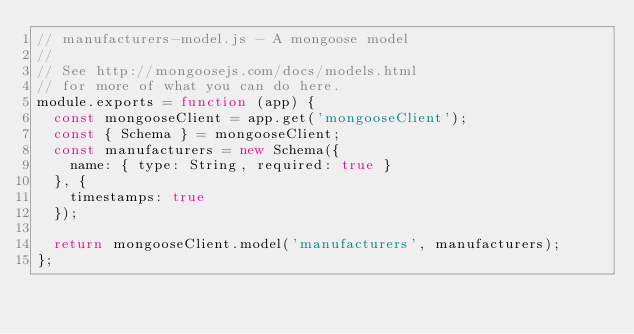<code> <loc_0><loc_0><loc_500><loc_500><_JavaScript_>// manufacturers-model.js - A mongoose model
// 
// See http://mongoosejs.com/docs/models.html
// for more of what you can do here.
module.exports = function (app) {
  const mongooseClient = app.get('mongooseClient');
  const { Schema } = mongooseClient;
  const manufacturers = new Schema({
    name: { type: String, required: true }
  }, {
    timestamps: true
  });

  return mongooseClient.model('manufacturers', manufacturers);
};
</code> 